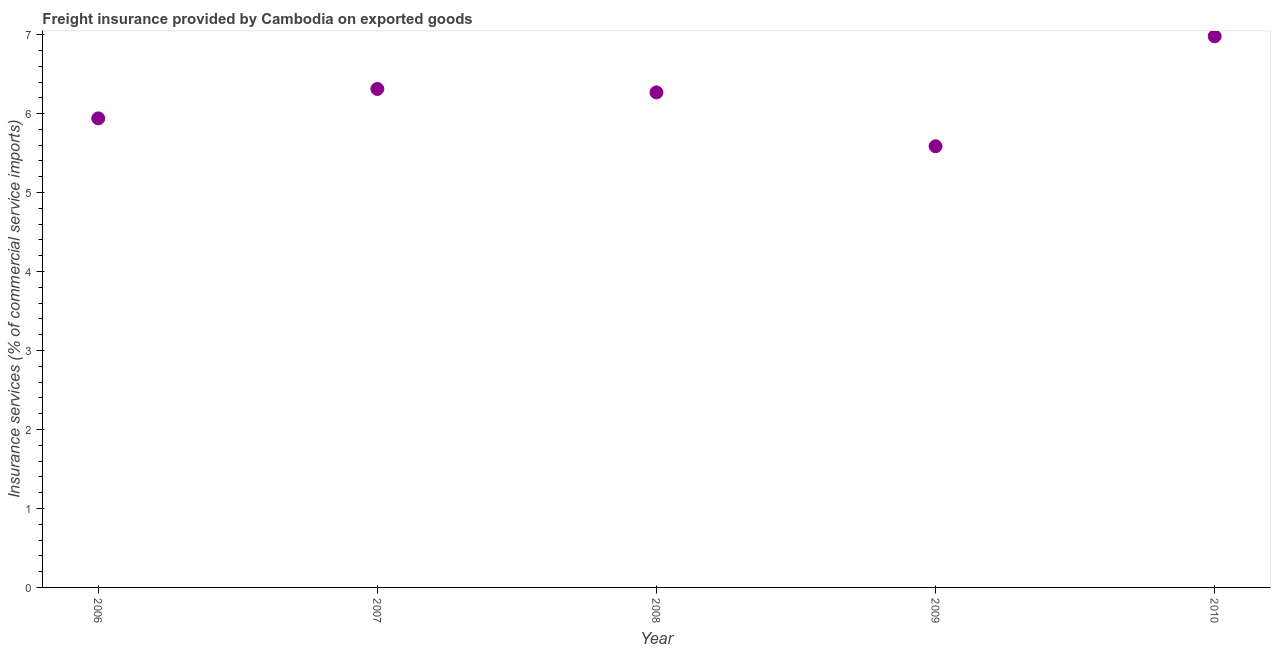What is the freight insurance in 2010?
Your answer should be very brief. 6.98. Across all years, what is the maximum freight insurance?
Ensure brevity in your answer.  6.98. Across all years, what is the minimum freight insurance?
Provide a short and direct response. 5.59. In which year was the freight insurance maximum?
Your answer should be very brief. 2010. In which year was the freight insurance minimum?
Your answer should be very brief. 2009. What is the sum of the freight insurance?
Your response must be concise. 31.09. What is the difference between the freight insurance in 2008 and 2010?
Keep it short and to the point. -0.71. What is the average freight insurance per year?
Your response must be concise. 6.22. What is the median freight insurance?
Keep it short and to the point. 6.27. Do a majority of the years between 2006 and 2008 (inclusive) have freight insurance greater than 5.2 %?
Offer a very short reply. Yes. What is the ratio of the freight insurance in 2007 to that in 2010?
Make the answer very short. 0.9. Is the freight insurance in 2008 less than that in 2010?
Your answer should be very brief. Yes. What is the difference between the highest and the second highest freight insurance?
Ensure brevity in your answer.  0.67. Is the sum of the freight insurance in 2006 and 2009 greater than the maximum freight insurance across all years?
Keep it short and to the point. Yes. What is the difference between the highest and the lowest freight insurance?
Offer a very short reply. 1.39. Does the freight insurance monotonically increase over the years?
Your answer should be very brief. No. How many dotlines are there?
Keep it short and to the point. 1. Are the values on the major ticks of Y-axis written in scientific E-notation?
Your response must be concise. No. Does the graph contain any zero values?
Keep it short and to the point. No. Does the graph contain grids?
Your response must be concise. No. What is the title of the graph?
Make the answer very short. Freight insurance provided by Cambodia on exported goods . What is the label or title of the X-axis?
Give a very brief answer. Year. What is the label or title of the Y-axis?
Provide a succinct answer. Insurance services (% of commercial service imports). What is the Insurance services (% of commercial service imports) in 2006?
Give a very brief answer. 5.94. What is the Insurance services (% of commercial service imports) in 2007?
Offer a very short reply. 6.31. What is the Insurance services (% of commercial service imports) in 2008?
Offer a very short reply. 6.27. What is the Insurance services (% of commercial service imports) in 2009?
Ensure brevity in your answer.  5.59. What is the Insurance services (% of commercial service imports) in 2010?
Your answer should be very brief. 6.98. What is the difference between the Insurance services (% of commercial service imports) in 2006 and 2007?
Offer a terse response. -0.37. What is the difference between the Insurance services (% of commercial service imports) in 2006 and 2008?
Your response must be concise. -0.33. What is the difference between the Insurance services (% of commercial service imports) in 2006 and 2009?
Provide a succinct answer. 0.35. What is the difference between the Insurance services (% of commercial service imports) in 2006 and 2010?
Give a very brief answer. -1.04. What is the difference between the Insurance services (% of commercial service imports) in 2007 and 2008?
Your answer should be compact. 0.04. What is the difference between the Insurance services (% of commercial service imports) in 2007 and 2009?
Ensure brevity in your answer.  0.73. What is the difference between the Insurance services (% of commercial service imports) in 2007 and 2010?
Your answer should be compact. -0.67. What is the difference between the Insurance services (% of commercial service imports) in 2008 and 2009?
Keep it short and to the point. 0.68. What is the difference between the Insurance services (% of commercial service imports) in 2008 and 2010?
Keep it short and to the point. -0.71. What is the difference between the Insurance services (% of commercial service imports) in 2009 and 2010?
Give a very brief answer. -1.39. What is the ratio of the Insurance services (% of commercial service imports) in 2006 to that in 2007?
Your answer should be compact. 0.94. What is the ratio of the Insurance services (% of commercial service imports) in 2006 to that in 2008?
Ensure brevity in your answer.  0.95. What is the ratio of the Insurance services (% of commercial service imports) in 2006 to that in 2009?
Provide a succinct answer. 1.06. What is the ratio of the Insurance services (% of commercial service imports) in 2006 to that in 2010?
Offer a terse response. 0.85. What is the ratio of the Insurance services (% of commercial service imports) in 2007 to that in 2009?
Provide a short and direct response. 1.13. What is the ratio of the Insurance services (% of commercial service imports) in 2007 to that in 2010?
Provide a succinct answer. 0.9. What is the ratio of the Insurance services (% of commercial service imports) in 2008 to that in 2009?
Provide a short and direct response. 1.12. What is the ratio of the Insurance services (% of commercial service imports) in 2008 to that in 2010?
Offer a terse response. 0.9. What is the ratio of the Insurance services (% of commercial service imports) in 2009 to that in 2010?
Provide a succinct answer. 0.8. 